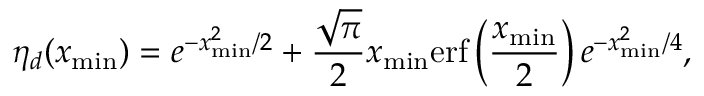<formula> <loc_0><loc_0><loc_500><loc_500>\eta _ { d } ( x _ { \min } ) = e ^ { - x _ { \min } ^ { 2 } / 2 } + \frac { \sqrt { \pi } } { 2 } x _ { \min } e r f \left ( \frac { x _ { \min } } { 2 } \right ) e ^ { - x _ { \min } ^ { 2 } / 4 } ,</formula> 